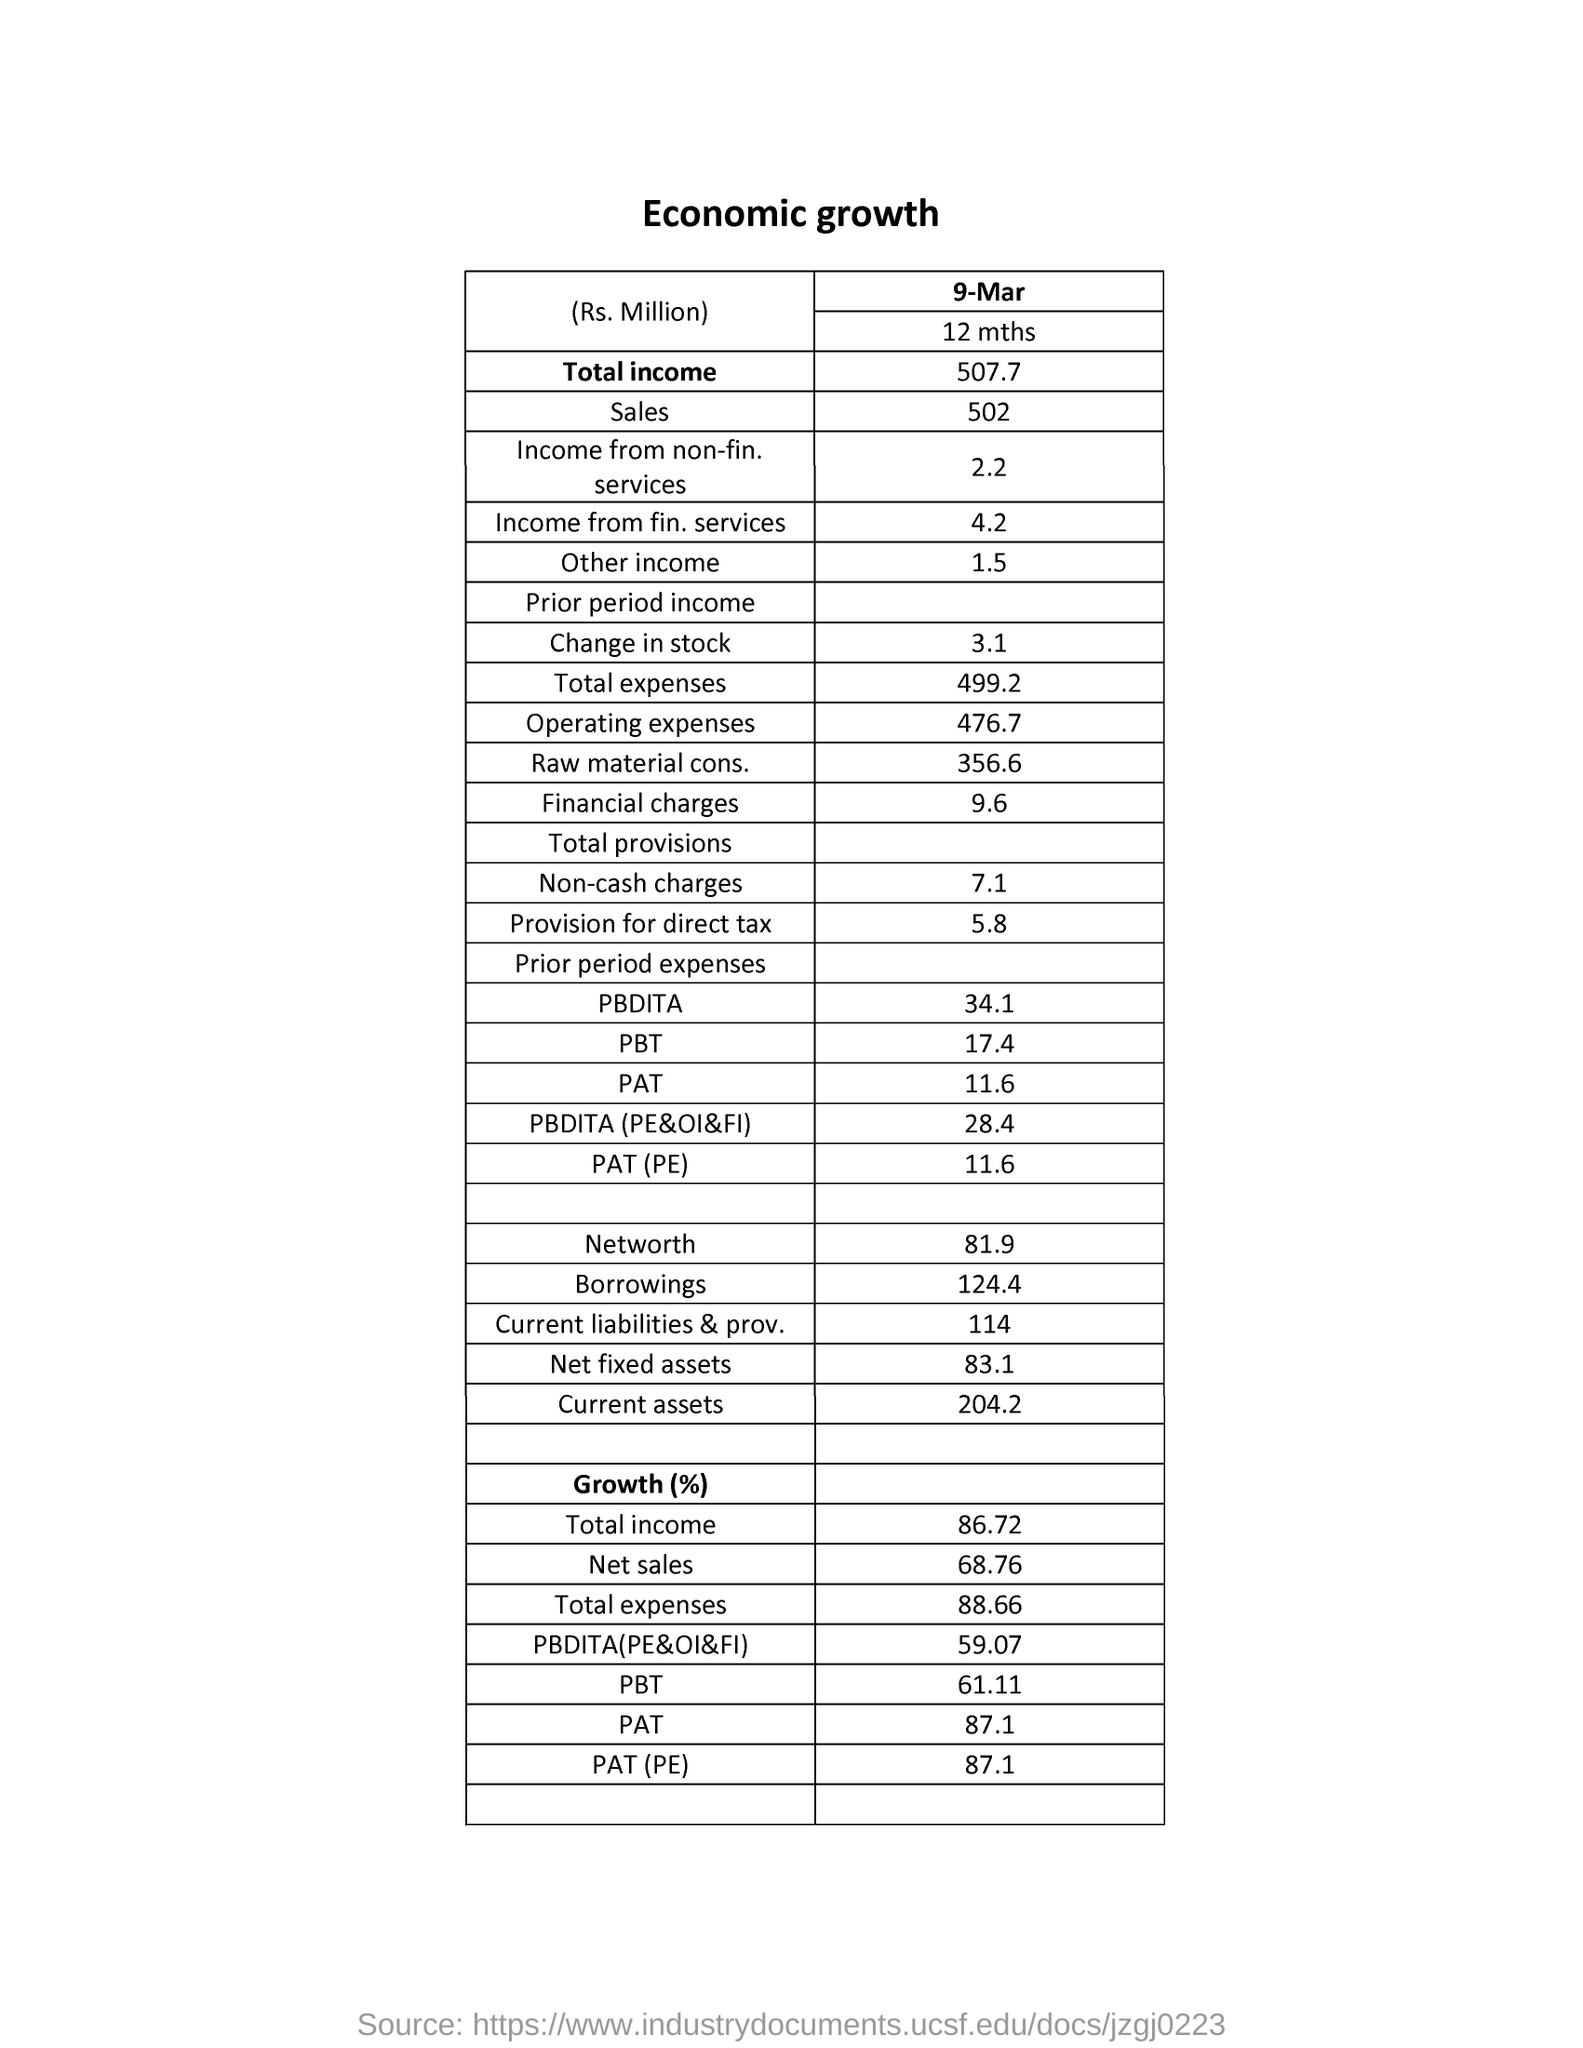How much is the "total expenses" of economic growth in millions?
Provide a short and direct response. 499.2. How much is the growth percentage for "PAT"?
Give a very brief answer. 87.1. What is the date specified in the document?
Provide a short and direct response. 9-MAR. How much amount is the "financial charges" in millions?
Provide a succinct answer. 9.6. How much is the "sales" amount in millions?
Your answer should be compact. 502. What is the percentage growth in "net sales"?
Your response must be concise. 68.76. How much is the "Non-cash charges" in millions?
Your answer should be very brief. 7.1. How much is the "Networth" amount in millions ?
Your answer should be very brief. 81.9. How much is the "current assets" amount in millions?
Offer a very short reply. 204 2. How much is the "Total expenses" in percentage?
Your response must be concise. 88.66. 